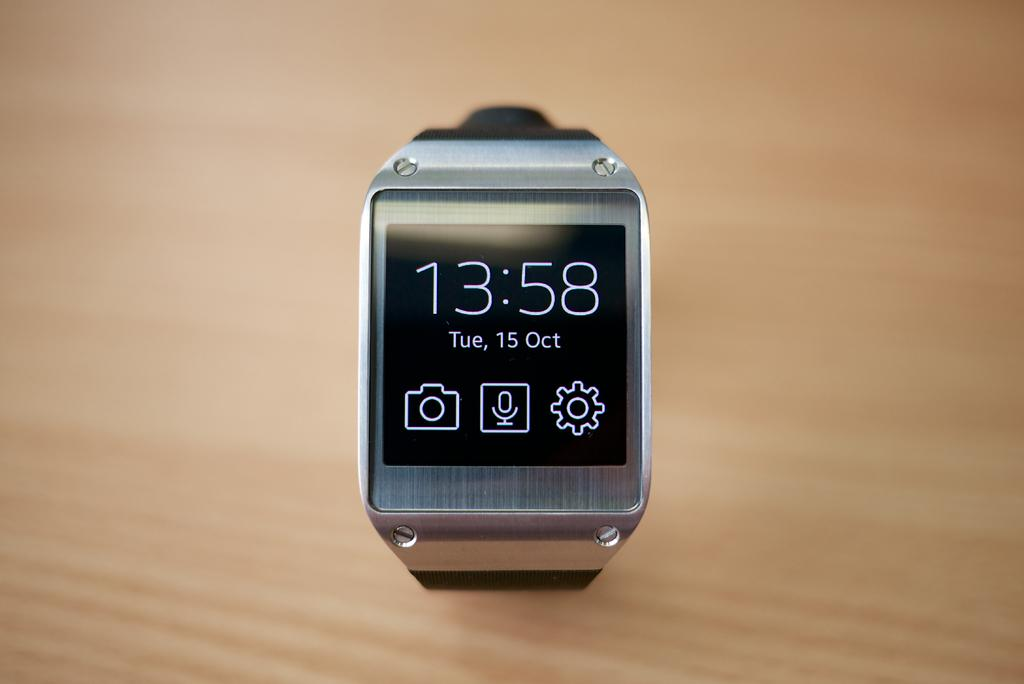<image>
Write a terse but informative summary of the picture. A smart watch says that the date is Tuesday, October 15. 